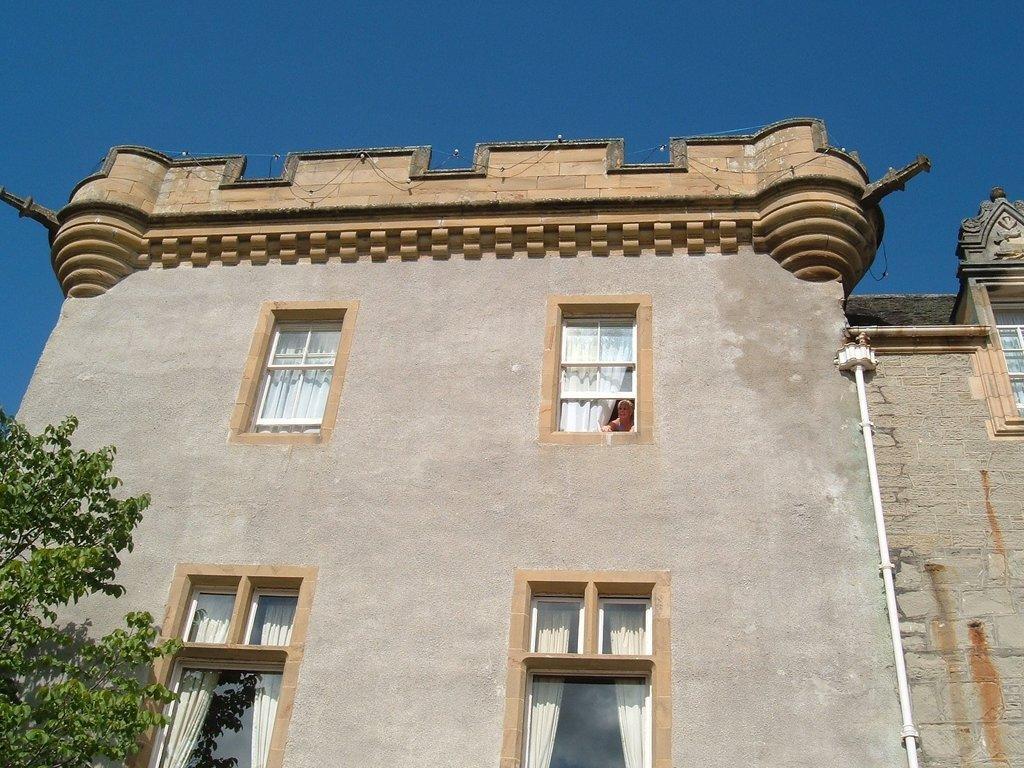Could you give a brief overview of what you see in this image? In this picture I can see there is a building and there are few windows, the windows have curtains and there is a tree on the left side and there is a pipeline at the right side. The sky is clear. 